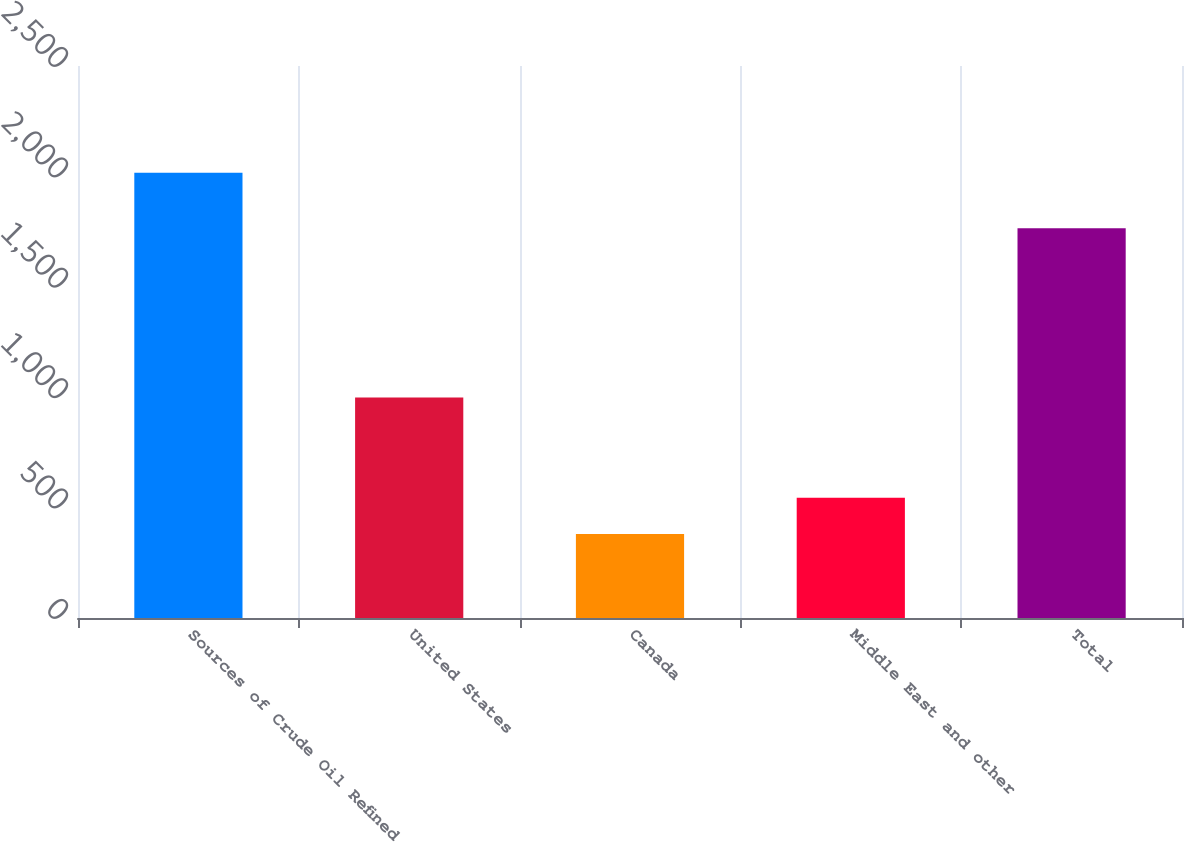<chart> <loc_0><loc_0><loc_500><loc_500><bar_chart><fcel>Sources of Crude Oil Refined<fcel>United States<fcel>Canada<fcel>Middle East and other<fcel>Total<nl><fcel>2017<fcel>999<fcel>381<fcel>544.6<fcel>1765<nl></chart> 